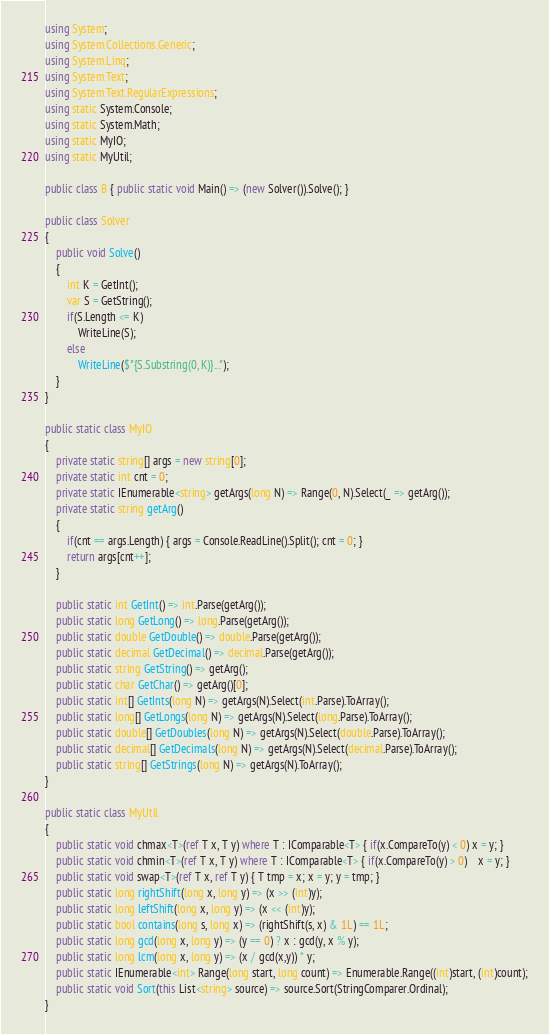<code> <loc_0><loc_0><loc_500><loc_500><_C#_>using System;
using System.Collections.Generic;
using System.Linq;
using System.Text;
using System.Text.RegularExpressions;
using static System.Console;
using static System.Math;
using static MyIO;
using static MyUtil;

public class B { public static void Main() => (new Solver()).Solve(); }

public class Solver
{
	public void Solve()
	{
		int K = GetInt();
		var S = GetString();
		if(S.Length <= K)
			WriteLine(S);
		else
			WriteLine($"{S.Substring(0, K)}...");
	}
}

public static class MyIO
{
	private static string[] args = new string[0];
	private static int cnt = 0;
	private static IEnumerable<string> getArgs(long N) => Range(0, N).Select(_ => getArg());
	private static string getArg()
	{
		if(cnt == args.Length) { args = Console.ReadLine().Split(); cnt = 0; }
		return args[cnt++];
	}

	public static int GetInt() => int.Parse(getArg());
	public static long GetLong() => long.Parse(getArg());
	public static double GetDouble() => double.Parse(getArg());
	public static decimal GetDecimal() => decimal.Parse(getArg());
	public static string GetString() => getArg();
	public static char GetChar() => getArg()[0];
	public static int[] GetInts(long N) => getArgs(N).Select(int.Parse).ToArray();
	public static long[] GetLongs(long N) => getArgs(N).Select(long.Parse).ToArray();
	public static double[] GetDoubles(long N) => getArgs(N).Select(double.Parse).ToArray();
	public static decimal[] GetDecimals(long N) => getArgs(N).Select(decimal.Parse).ToArray();
	public static string[] GetStrings(long N) => getArgs(N).ToArray();
}

public static class MyUtil
{
	public static void chmax<T>(ref T x, T y) where T : IComparable<T> { if(x.CompareTo(y) < 0) x = y; }
	public static void chmin<T>(ref T x, T y) where T : IComparable<T> { if(x.CompareTo(y) > 0)	x = y; }
	public static void swap<T>(ref T x, ref T y) { T tmp = x; x = y; y = tmp; }
	public static long rightShift(long x, long y) => (x >> (int)y);
	public static long leftShift(long x, long y) => (x << (int)y);
	public static bool contains(long s, long x) => (rightShift(s, x) & 1L) == 1L;
	public static long gcd(long x, long y) => (y == 0) ? x : gcd(y, x % y);
	public static long lcm(long x, long y) => (x / gcd(x,y)) * y;	
	public static IEnumerable<int> Range(long start, long count) => Enumerable.Range((int)start, (int)count);
	public static void Sort(this List<string> source) => source.Sort(StringComparer.Ordinal);
}
</code> 